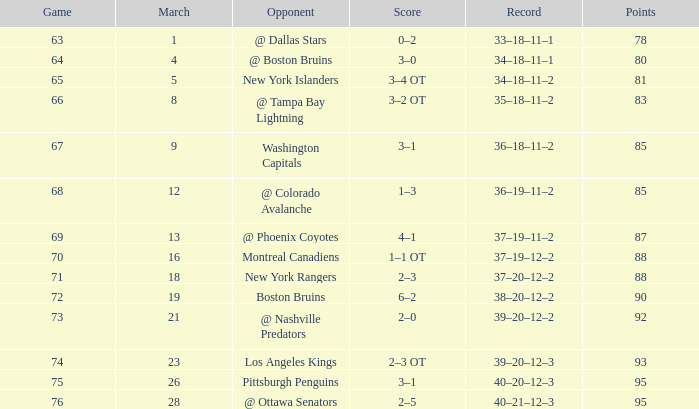Which rival has a statistic of 38-20-12-2? Boston Bruins. 